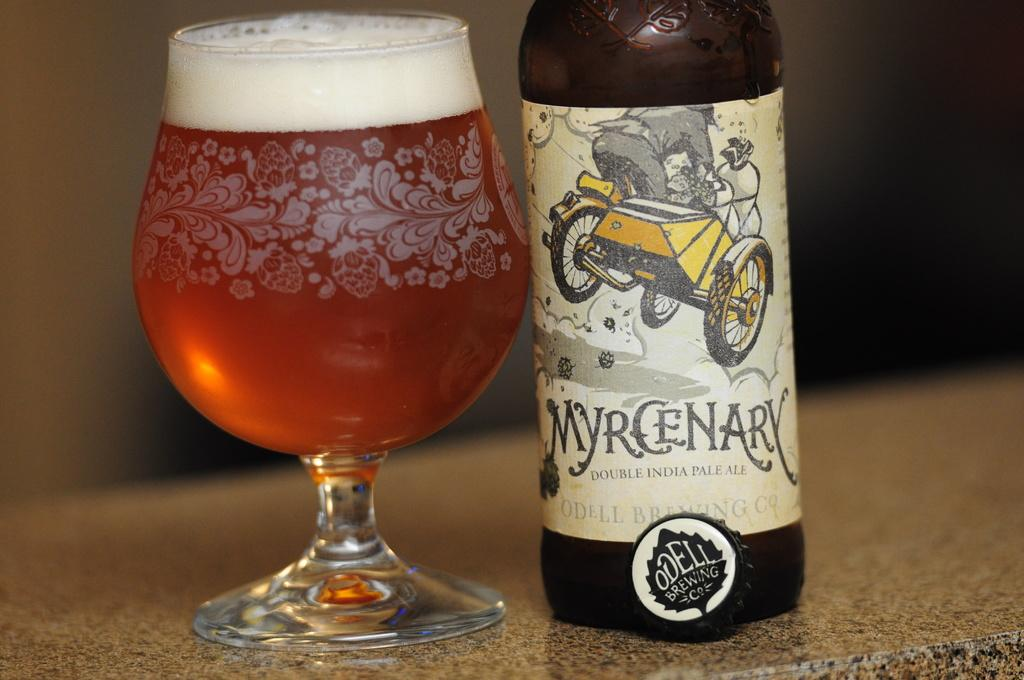<image>
Write a terse but informative summary of the picture. the word myrcenary that is next to a cup of beer 